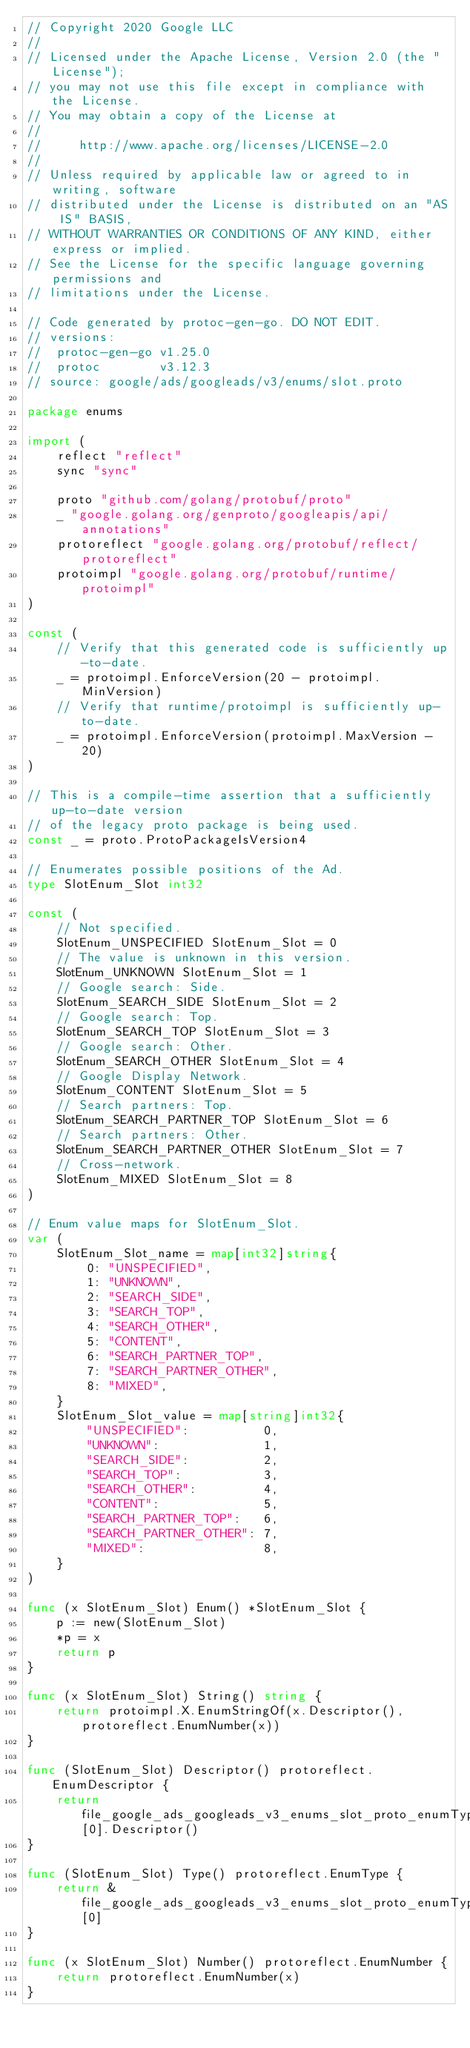<code> <loc_0><loc_0><loc_500><loc_500><_Go_>// Copyright 2020 Google LLC
//
// Licensed under the Apache License, Version 2.0 (the "License");
// you may not use this file except in compliance with the License.
// You may obtain a copy of the License at
//
//     http://www.apache.org/licenses/LICENSE-2.0
//
// Unless required by applicable law or agreed to in writing, software
// distributed under the License is distributed on an "AS IS" BASIS,
// WITHOUT WARRANTIES OR CONDITIONS OF ANY KIND, either express or implied.
// See the License for the specific language governing permissions and
// limitations under the License.

// Code generated by protoc-gen-go. DO NOT EDIT.
// versions:
// 	protoc-gen-go v1.25.0
// 	protoc        v3.12.3
// source: google/ads/googleads/v3/enums/slot.proto

package enums

import (
	reflect "reflect"
	sync "sync"

	proto "github.com/golang/protobuf/proto"
	_ "google.golang.org/genproto/googleapis/api/annotations"
	protoreflect "google.golang.org/protobuf/reflect/protoreflect"
	protoimpl "google.golang.org/protobuf/runtime/protoimpl"
)

const (
	// Verify that this generated code is sufficiently up-to-date.
	_ = protoimpl.EnforceVersion(20 - protoimpl.MinVersion)
	// Verify that runtime/protoimpl is sufficiently up-to-date.
	_ = protoimpl.EnforceVersion(protoimpl.MaxVersion - 20)
)

// This is a compile-time assertion that a sufficiently up-to-date version
// of the legacy proto package is being used.
const _ = proto.ProtoPackageIsVersion4

// Enumerates possible positions of the Ad.
type SlotEnum_Slot int32

const (
	// Not specified.
	SlotEnum_UNSPECIFIED SlotEnum_Slot = 0
	// The value is unknown in this version.
	SlotEnum_UNKNOWN SlotEnum_Slot = 1
	// Google search: Side.
	SlotEnum_SEARCH_SIDE SlotEnum_Slot = 2
	// Google search: Top.
	SlotEnum_SEARCH_TOP SlotEnum_Slot = 3
	// Google search: Other.
	SlotEnum_SEARCH_OTHER SlotEnum_Slot = 4
	// Google Display Network.
	SlotEnum_CONTENT SlotEnum_Slot = 5
	// Search partners: Top.
	SlotEnum_SEARCH_PARTNER_TOP SlotEnum_Slot = 6
	// Search partners: Other.
	SlotEnum_SEARCH_PARTNER_OTHER SlotEnum_Slot = 7
	// Cross-network.
	SlotEnum_MIXED SlotEnum_Slot = 8
)

// Enum value maps for SlotEnum_Slot.
var (
	SlotEnum_Slot_name = map[int32]string{
		0: "UNSPECIFIED",
		1: "UNKNOWN",
		2: "SEARCH_SIDE",
		3: "SEARCH_TOP",
		4: "SEARCH_OTHER",
		5: "CONTENT",
		6: "SEARCH_PARTNER_TOP",
		7: "SEARCH_PARTNER_OTHER",
		8: "MIXED",
	}
	SlotEnum_Slot_value = map[string]int32{
		"UNSPECIFIED":          0,
		"UNKNOWN":              1,
		"SEARCH_SIDE":          2,
		"SEARCH_TOP":           3,
		"SEARCH_OTHER":         4,
		"CONTENT":              5,
		"SEARCH_PARTNER_TOP":   6,
		"SEARCH_PARTNER_OTHER": 7,
		"MIXED":                8,
	}
)

func (x SlotEnum_Slot) Enum() *SlotEnum_Slot {
	p := new(SlotEnum_Slot)
	*p = x
	return p
}

func (x SlotEnum_Slot) String() string {
	return protoimpl.X.EnumStringOf(x.Descriptor(), protoreflect.EnumNumber(x))
}

func (SlotEnum_Slot) Descriptor() protoreflect.EnumDescriptor {
	return file_google_ads_googleads_v3_enums_slot_proto_enumTypes[0].Descriptor()
}

func (SlotEnum_Slot) Type() protoreflect.EnumType {
	return &file_google_ads_googleads_v3_enums_slot_proto_enumTypes[0]
}

func (x SlotEnum_Slot) Number() protoreflect.EnumNumber {
	return protoreflect.EnumNumber(x)
}
</code> 